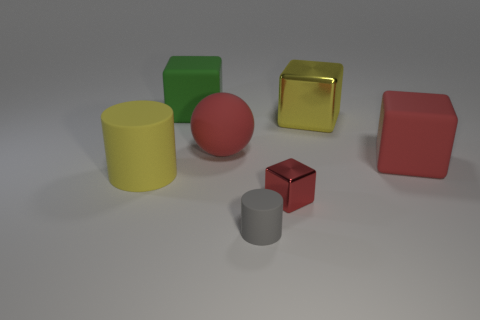How many big cylinders are the same color as the small cube?
Keep it short and to the point. 0. What is the shape of the yellow rubber object that is the same size as the green cube?
Provide a succinct answer. Cylinder. Is there another large green matte object of the same shape as the large green matte object?
Your answer should be compact. No. What number of green cylinders are the same material as the ball?
Your response must be concise. 0. Are the small red cube in front of the ball and the green block made of the same material?
Ensure brevity in your answer.  No. Are there more rubber cylinders behind the big yellow matte object than large yellow objects on the right side of the big red block?
Give a very brief answer. No. There is a red ball that is the same size as the green matte object; what material is it?
Provide a short and direct response. Rubber. How many other things are there of the same material as the small gray cylinder?
Your answer should be very brief. 4. There is a metallic object that is in front of the yellow shiny block; is it the same shape as the yellow object behind the yellow rubber object?
Your answer should be very brief. Yes. What number of other objects are there of the same color as the large metal cube?
Offer a very short reply. 1. 